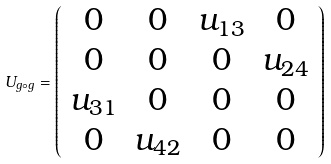<formula> <loc_0><loc_0><loc_500><loc_500>U _ { g \circ g } = \left ( \begin{array} { c c c c } 0 & 0 & u _ { 1 3 } & 0 \\ 0 & 0 & 0 & u _ { 2 4 } \\ u _ { 3 1 } & 0 & 0 & 0 \\ 0 & u _ { 4 2 } & 0 & 0 \end{array} \right )</formula> 